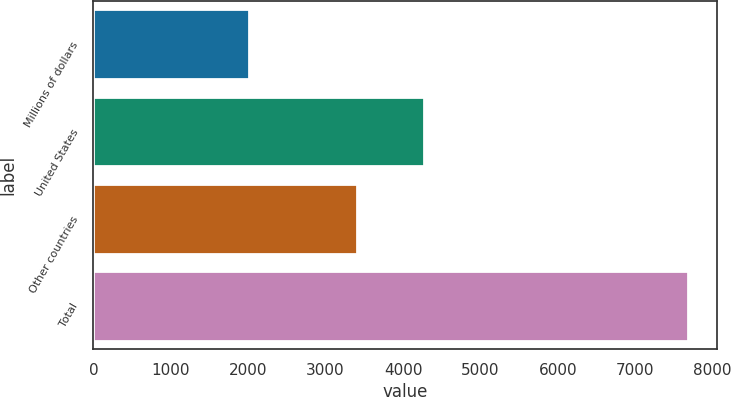Convert chart to OTSL. <chart><loc_0><loc_0><loc_500><loc_500><bar_chart><fcel>Millions of dollars<fcel>United States<fcel>Other countries<fcel>Total<nl><fcel>2009<fcel>4274<fcel>3401<fcel>7675<nl></chart> 